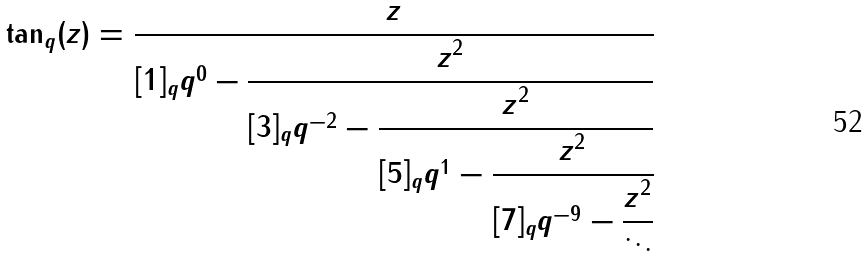<formula> <loc_0><loc_0><loc_500><loc_500>\tan _ { q } ( z ) = \cfrac { z } { [ 1 ] _ { q } q ^ { 0 } - \cfrac { z ^ { 2 } } { [ 3 ] _ { q } q ^ { - 2 } - \cfrac { z ^ { 2 } } { [ 5 ] _ { q } q ^ { 1 } - \cfrac { z ^ { 2 } } { [ 7 ] _ { q } q ^ { - 9 } - \cfrac { z ^ { 2 } } { \ddots } } } } }</formula> 